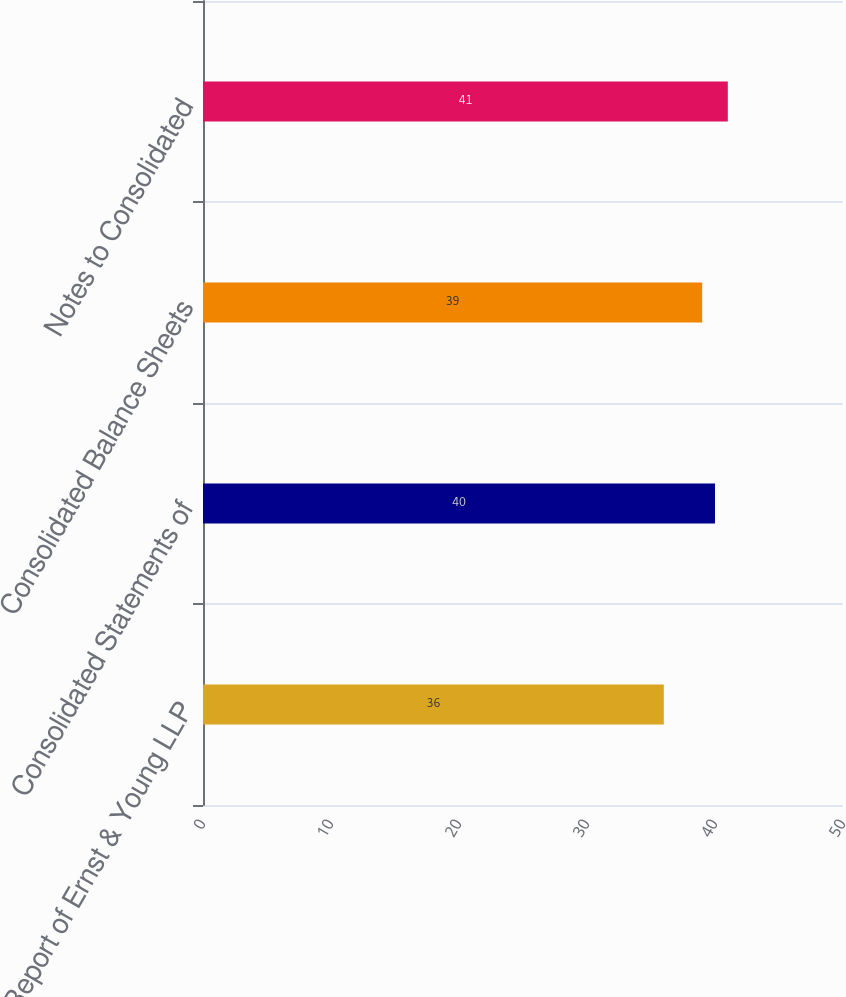Convert chart. <chart><loc_0><loc_0><loc_500><loc_500><bar_chart><fcel>Report of Ernst & Young LLP<fcel>Consolidated Statements of<fcel>Consolidated Balance Sheets<fcel>Notes to Consolidated<nl><fcel>36<fcel>40<fcel>39<fcel>41<nl></chart> 